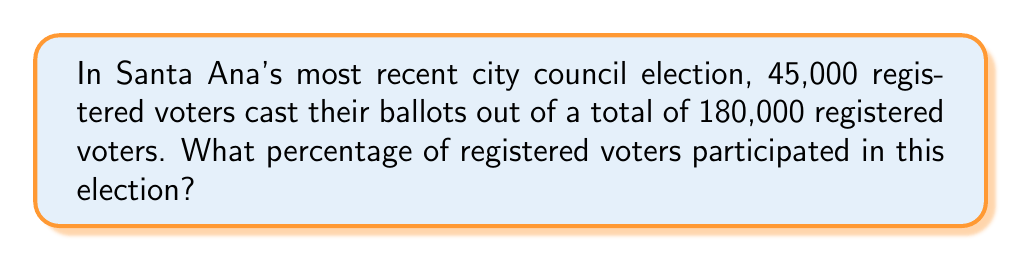Can you solve this math problem? To solve this problem, we need to follow these steps:

1. Identify the given information:
   - Number of voters who participated: 45,000
   - Total number of registered voters: 180,000

2. Set up the percentage formula:
   $$ \text{Percentage} = \frac{\text{Part}}{\text{Whole}} \times 100\% $$

3. Plug in the values:
   $$ \text{Percentage} = \frac{45,000}{180,000} \times 100\% $$

4. Simplify the fraction:
   $$ \text{Percentage} = \frac{1}{4} \times 100\% $$

5. Perform the multiplication:
   $$ \text{Percentage} = 0.25 \times 100\% = 25\% $$

Therefore, 25% of registered voters in Santa Ana participated in the most recent city council election.
Answer: 25% 